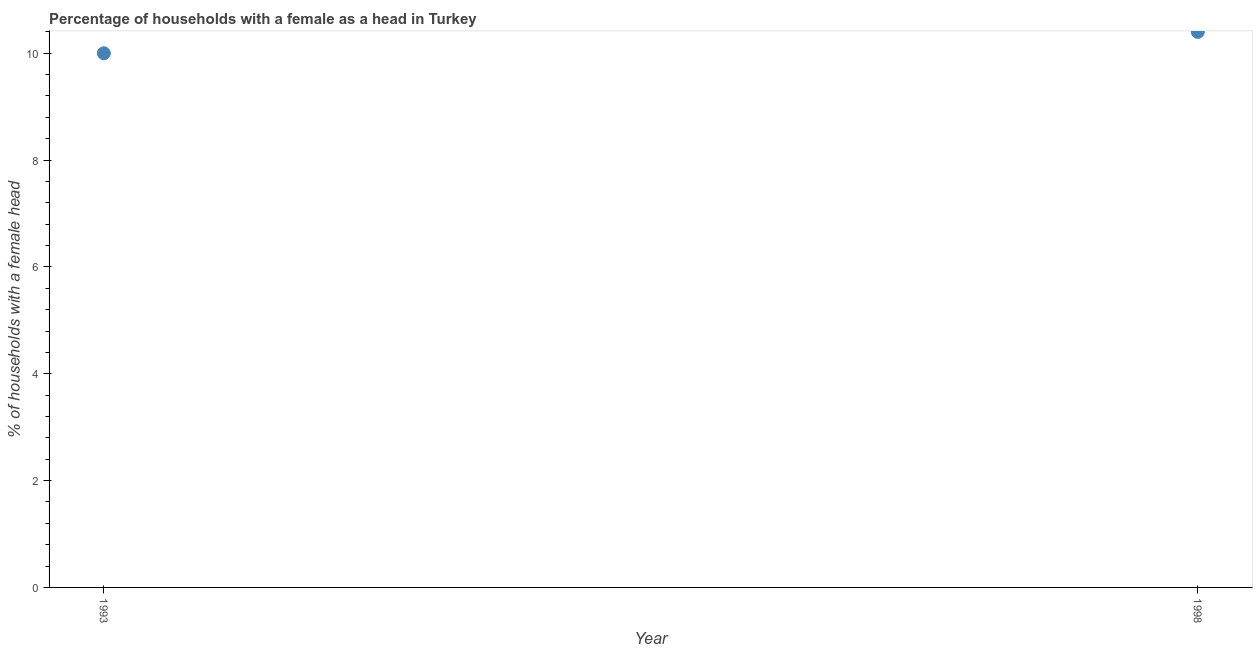Across all years, what is the maximum number of female supervised households?
Offer a very short reply. 10.4. Across all years, what is the minimum number of female supervised households?
Ensure brevity in your answer.  10. In which year was the number of female supervised households minimum?
Offer a very short reply. 1993. What is the sum of the number of female supervised households?
Ensure brevity in your answer.  20.4. What is the difference between the number of female supervised households in 1993 and 1998?
Your answer should be very brief. -0.4. What is the average number of female supervised households per year?
Offer a terse response. 10.2. In how many years, is the number of female supervised households greater than 8.8 %?
Offer a terse response. 2. What is the ratio of the number of female supervised households in 1993 to that in 1998?
Provide a succinct answer. 0.96. Is the number of female supervised households in 1993 less than that in 1998?
Ensure brevity in your answer.  Yes. In how many years, is the number of female supervised households greater than the average number of female supervised households taken over all years?
Ensure brevity in your answer.  1. Does the number of female supervised households monotonically increase over the years?
Provide a short and direct response. Yes. What is the difference between two consecutive major ticks on the Y-axis?
Provide a succinct answer. 2. What is the title of the graph?
Offer a terse response. Percentage of households with a female as a head in Turkey. What is the label or title of the X-axis?
Offer a terse response. Year. What is the label or title of the Y-axis?
Provide a short and direct response. % of households with a female head. What is the % of households with a female head in 1993?
Your answer should be very brief. 10. What is the % of households with a female head in 1998?
Your response must be concise. 10.4. What is the difference between the % of households with a female head in 1993 and 1998?
Offer a very short reply. -0.4. What is the ratio of the % of households with a female head in 1993 to that in 1998?
Your answer should be compact. 0.96. 